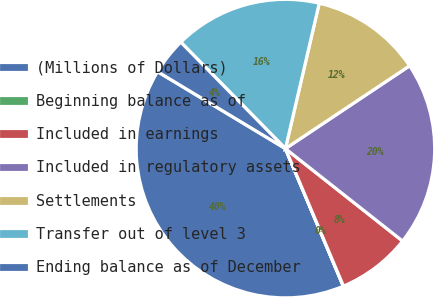Convert chart to OTSL. <chart><loc_0><loc_0><loc_500><loc_500><pie_chart><fcel>(Millions of Dollars)<fcel>Beginning balance as of<fcel>Included in earnings<fcel>Included in regulatory assets<fcel>Settlements<fcel>Transfer out of level 3<fcel>Ending balance as of December<nl><fcel>39.96%<fcel>0.02%<fcel>8.01%<fcel>19.99%<fcel>12.0%<fcel>16.0%<fcel>4.01%<nl></chart> 